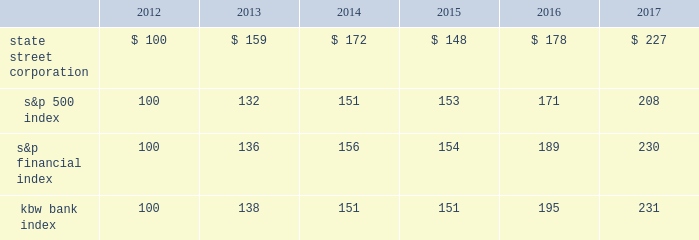State street corporation | 52 shareholder return performance presentation the graph presented below compares the cumulative total shareholder return on state street's common stock to the cumulative total return of the s&p 500 index , the s&p financial index and the kbw bank index over a five-year period .
The cumulative total shareholder return assumes the investment of $ 100 in state street common stock and in each index on december 31 , 2012 .
It also assumes reinvestment of common stock dividends .
The s&p financial index is a publicly available , capitalization-weighted index , comprised of 67 of the standard & poor 2019s 500 companies , representing 27 diversified financial services companies , 23 insurance companies , and 17 banking companies .
The kbw bank index is a modified cap-weighted index consisting of 24 exchange-listed stocks , representing national money center banks and leading regional institutions. .

What is the roi of an investment is s&p500 index from 2012 to 2015? 
Computations: ((153 - 100) / 100)
Answer: 0.53. 